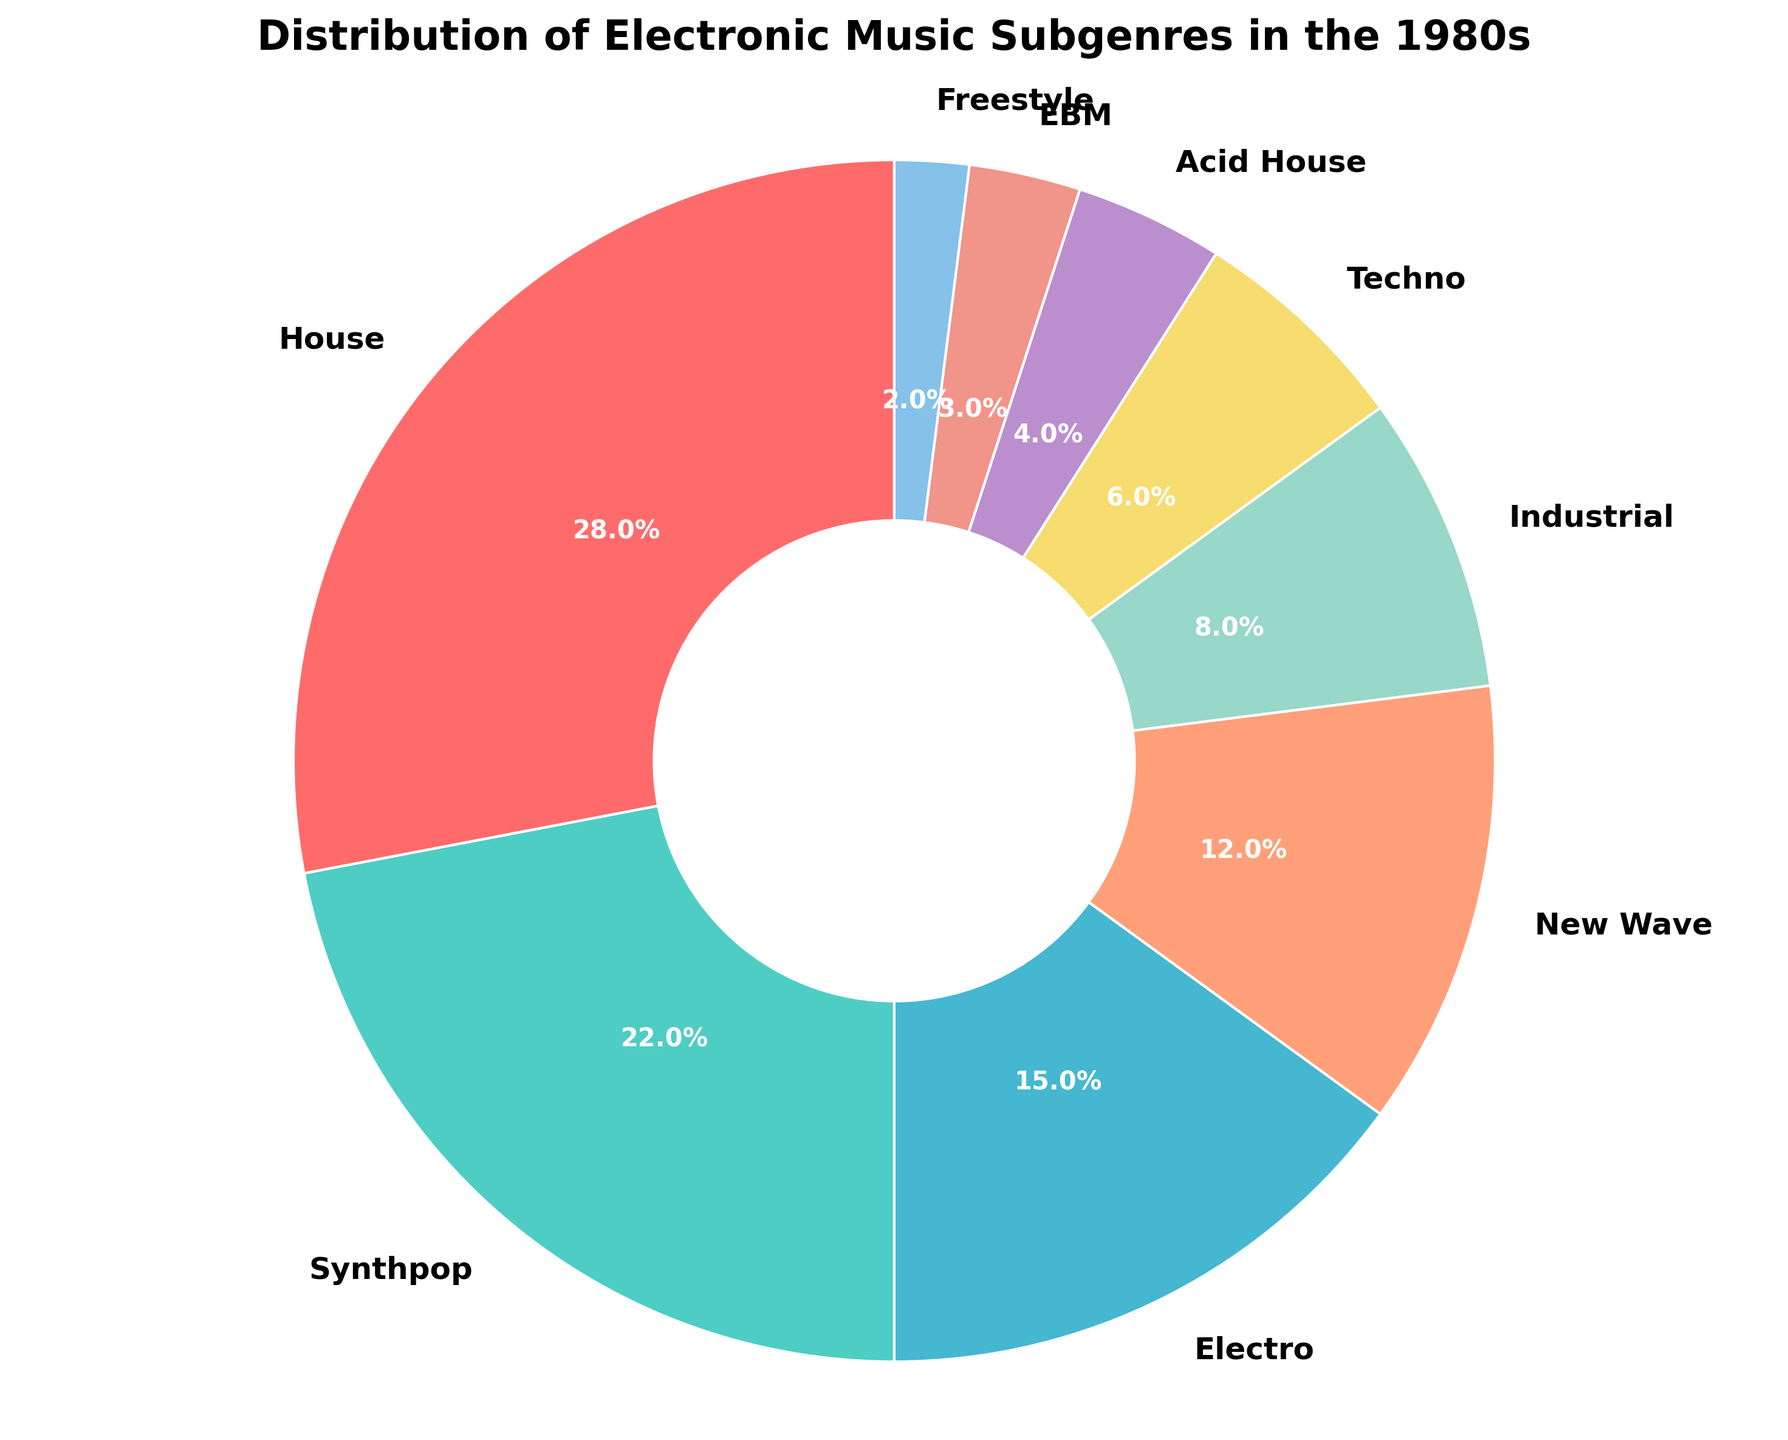Which subgenre has the highest percentage? To find the subgenre with the highest percentage, examine the figure and look at the labels and their corresponding percentages. The subgenre with the highest percentage is House.
Answer: House What is the combined percentage of Electro and New Wave? Add the percentages of Electro (15%) and New Wave (12%). So, 15% + 12% = 27%.
Answer: 27% Which subgenre has a greater percentage, Techno or Industrial? Compare the percentages of Techno (6%) and Industrial (8%). Industrial has a greater percentage than Techno.
Answer: Industrial How much higher is the percentage of House compared to Synthpop? Subtract the percentage of Synthpop (22%) from the percentage of House (28%). So, 28% - 22% = 6%.
Answer: 6% Which subgenre has the smallest percentage and what is it? Identify the subgenre with the smallest visual wedge. Freestyle has the smallest percentage at 2%.
Answer: Freestyle, 2% What is the combined percentage of the three smallest subgenres? Add the percentages of Acid House (4%), EBM (3%), and Freestyle (2%). So, 4% + 3% + 2% = 9%.
Answer: 9% Which subgenre occupies a larger portion of the pie, Synthpop or Electro? Compare the percentages of Synthpop (22%) and Electro (15%). Synthpop occupies a larger portion of the pie.
Answer: Synthpop What is the difference in percentage between the most popular and least popular subgenres? Subtract the percentage of the least popular subgenre, Freestyle (2%), from the most popular subgenre, House (28%). So, 28% - 2% = 26%.
Answer: 26% What is the total percentage covered by subgenres with more than 10% each? Add the percentages of House (28%), Synthpop (22%), Electro (15%), and New Wave (12%). So, 28% + 22% + 15% + 12% = 77%.
Answer: 77% Is there any subgenre with a percentage equal to or less than 5%? If so, which one? Check the figure for subgenres with percentages that are 5% or less. The subgenres are Acid House (4%), EBM (3%), and Freestyle (2%).
Answer: Acid House, EBM, Freestyle 